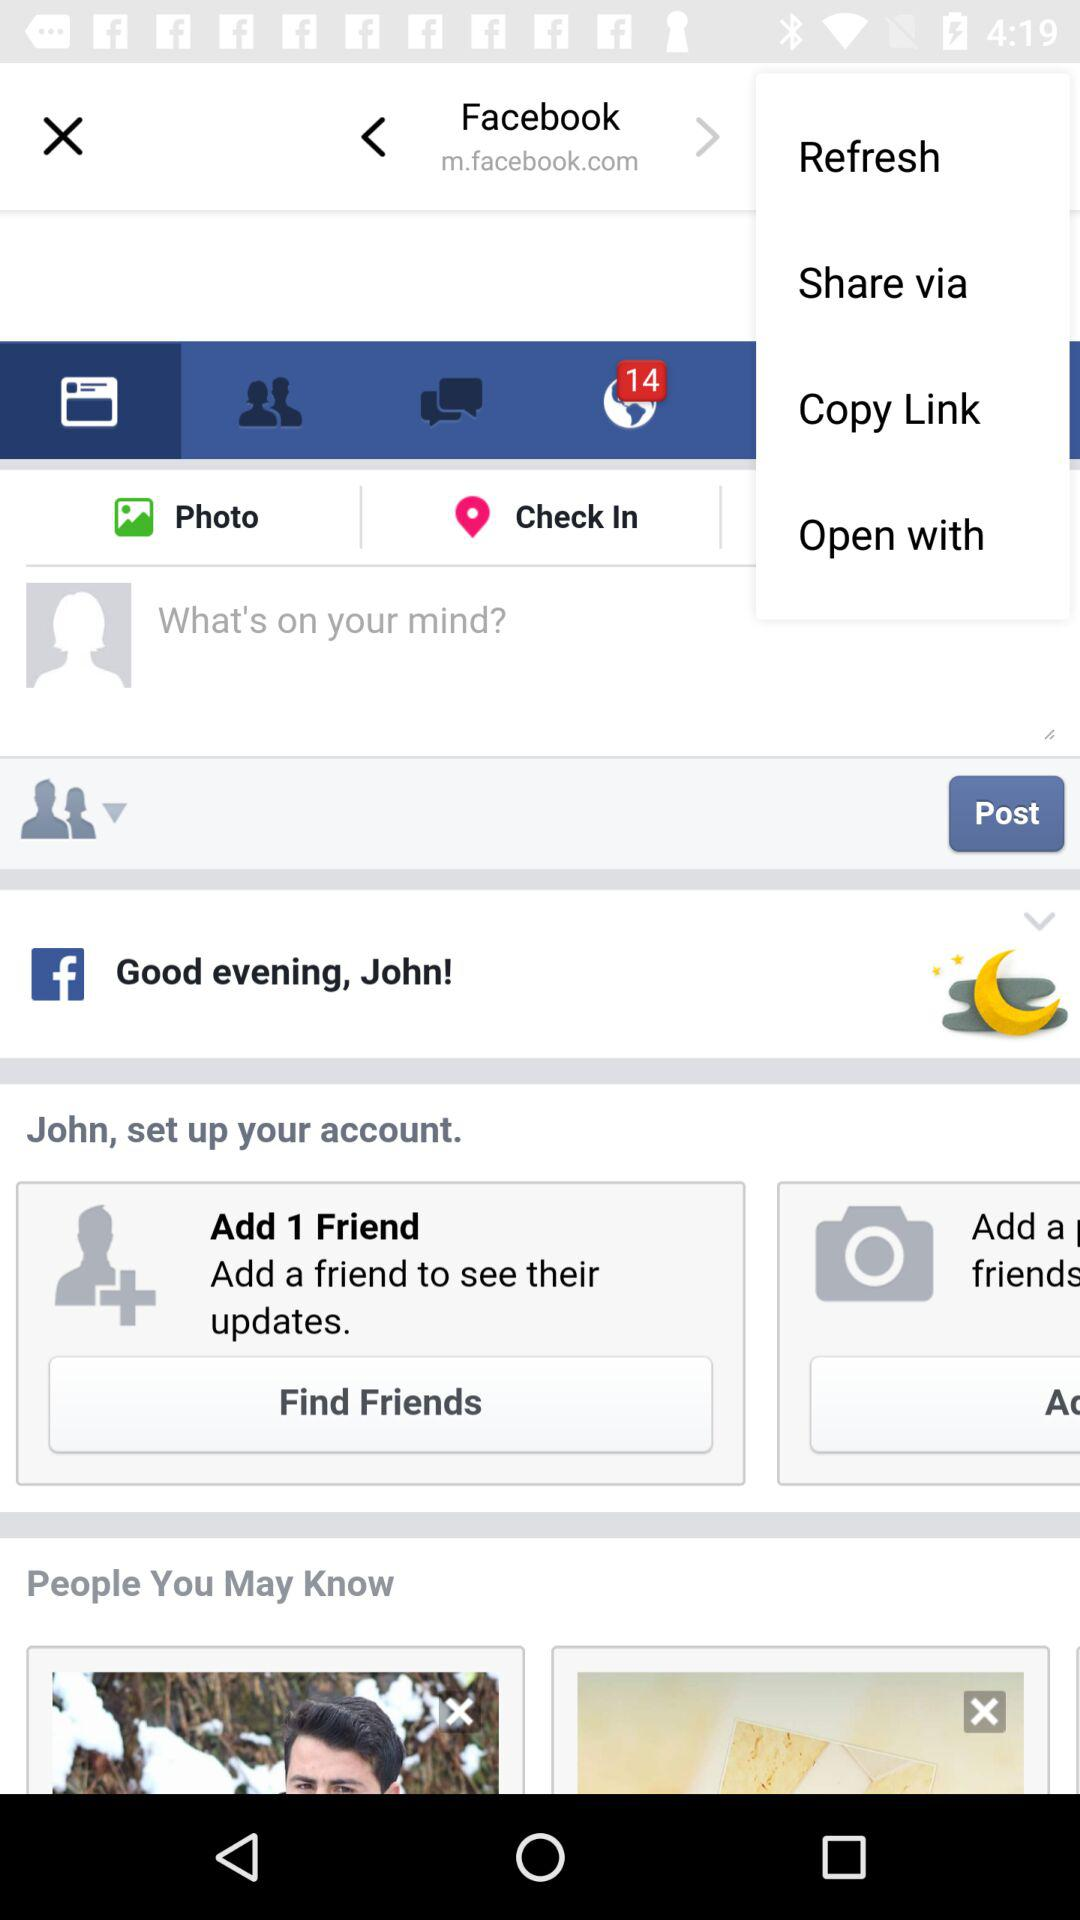What is the name of the user? The name of the user is "John". 